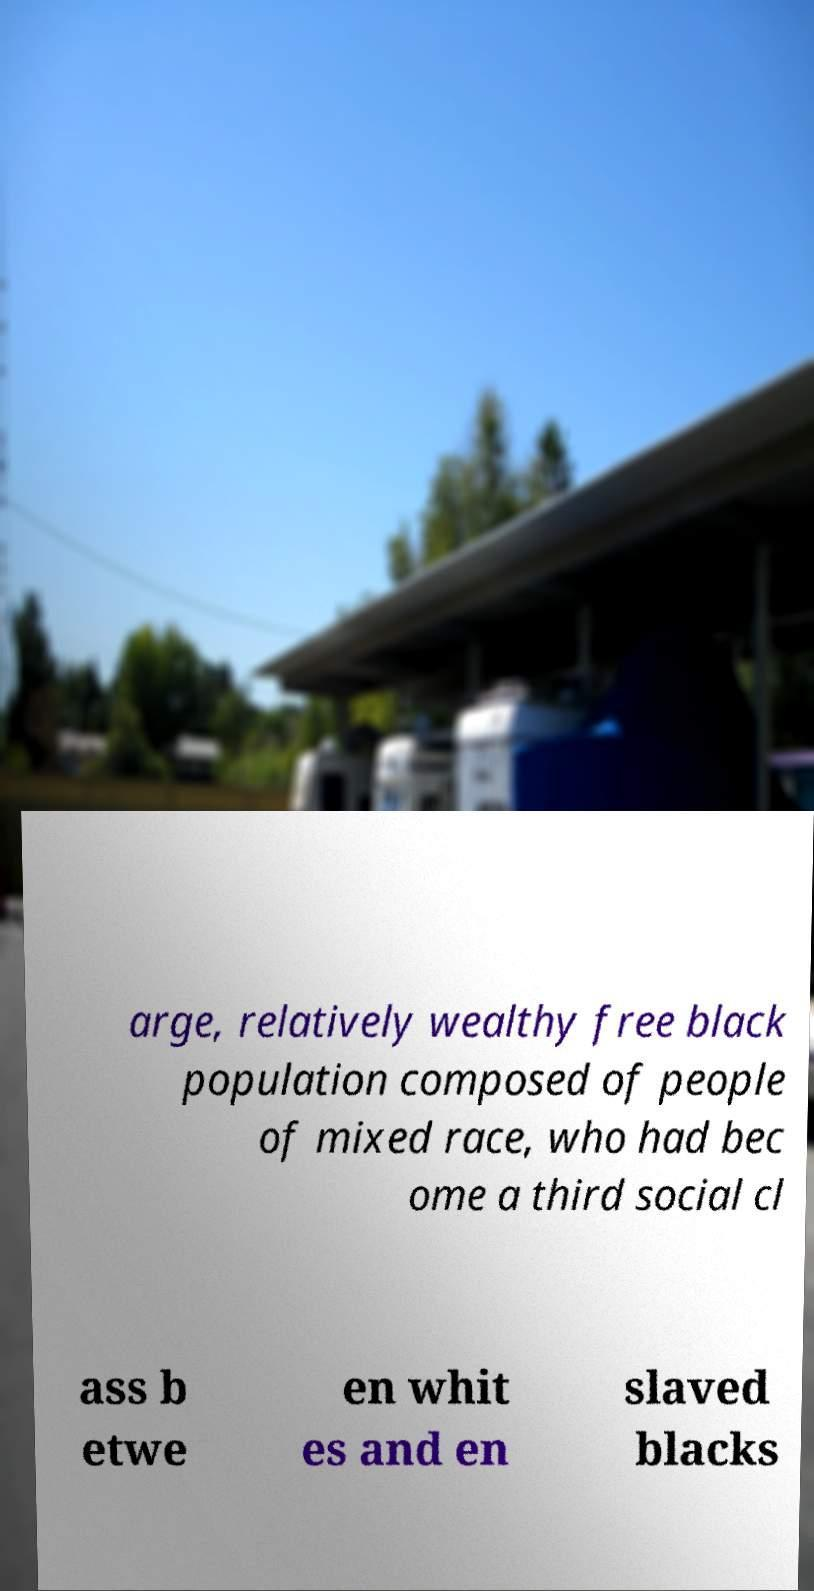For documentation purposes, I need the text within this image transcribed. Could you provide that? arge, relatively wealthy free black population composed of people of mixed race, who had bec ome a third social cl ass b etwe en whit es and en slaved blacks 